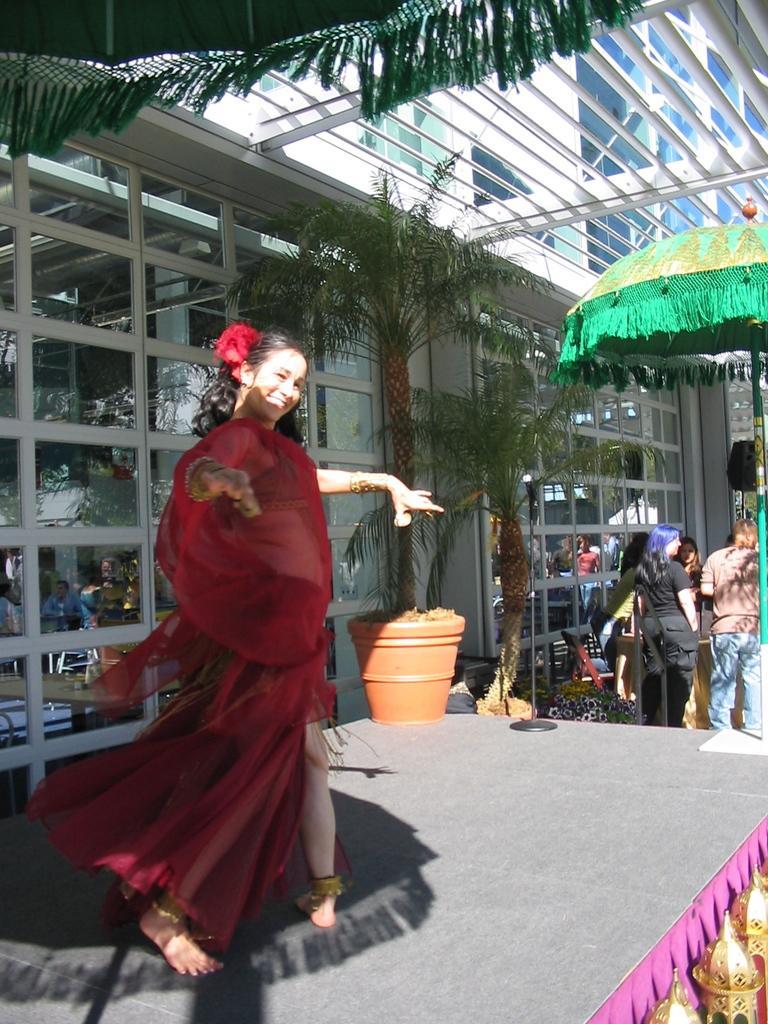How would you summarize this image in a sentence or two? On the left side of this image there is a woman smiling and dancing on the stage. At one corner of the stage there is a pot. On the right side few people are standing under the umbrella. Beside them there are few plants. In the background there is a building. In the bottom right-hand corner there are few objects. 